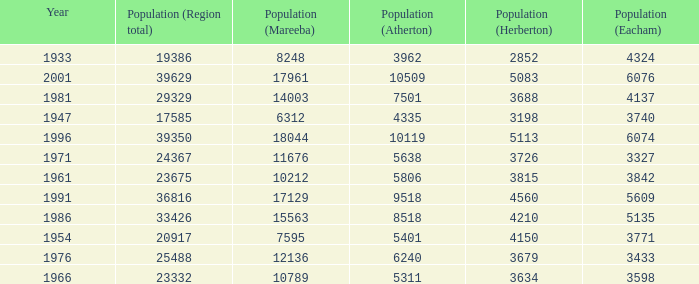What was the smallest population figure for Mareeba? 6312.0. Would you mind parsing the complete table? {'header': ['Year', 'Population (Region total)', 'Population (Mareeba)', 'Population (Atherton)', 'Population (Herberton)', 'Population (Eacham)'], 'rows': [['1933', '19386', '8248', '3962', '2852', '4324'], ['2001', '39629', '17961', '10509', '5083', '6076'], ['1981', '29329', '14003', '7501', '3688', '4137'], ['1947', '17585', '6312', '4335', '3198', '3740'], ['1996', '39350', '18044', '10119', '5113', '6074'], ['1971', '24367', '11676', '5638', '3726', '3327'], ['1961', '23675', '10212', '5806', '3815', '3842'], ['1991', '36816', '17129', '9518', '4560', '5609'], ['1986', '33426', '15563', '8518', '4210', '5135'], ['1954', '20917', '7595', '5401', '4150', '3771'], ['1976', '25488', '12136', '6240', '3679', '3433'], ['1966', '23332', '10789', '5311', '3634', '3598']]} 